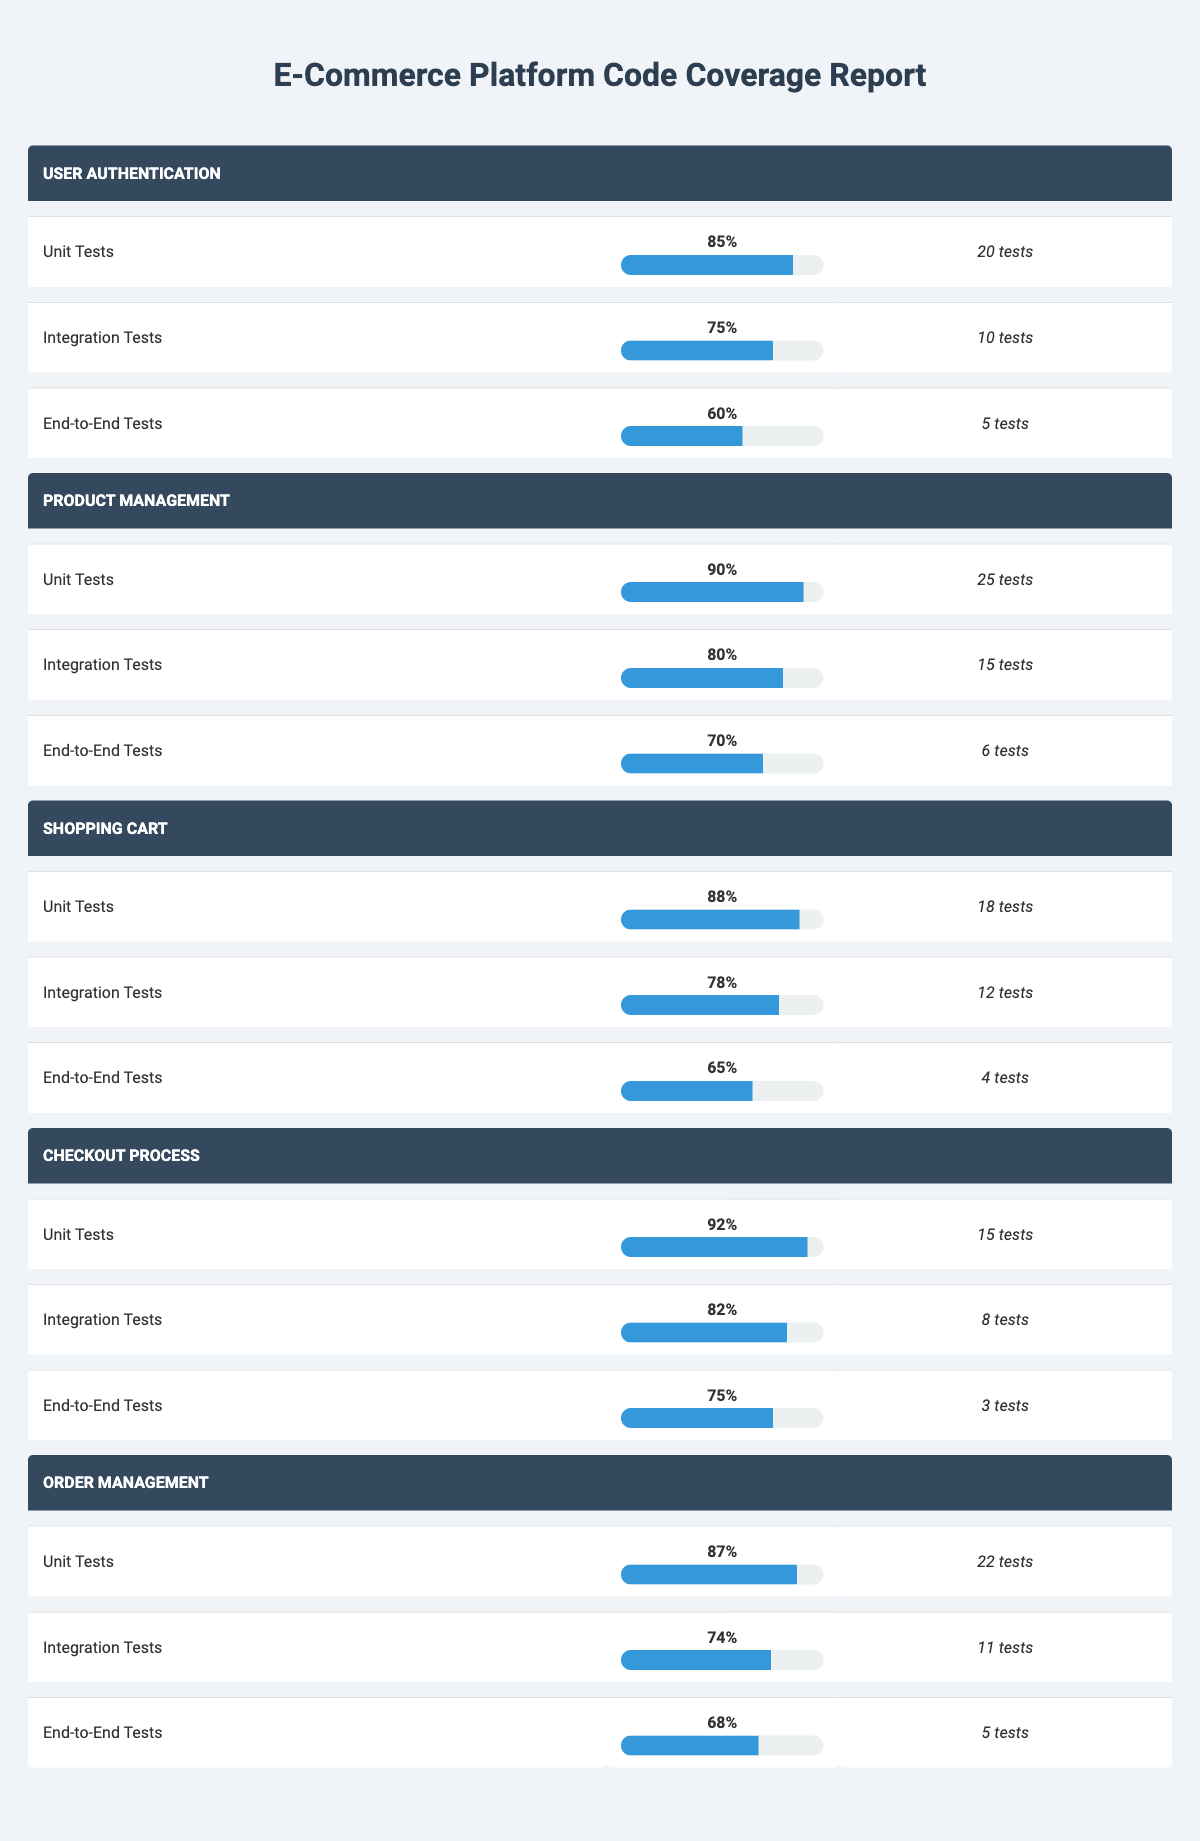What is the coverage percentage for Unit Tests in the Checkout Process module? The coverage percentage for Unit Tests in the Checkout Process module is listed directly in the table under the respective module and test type row. It shows 92% as the coverage for Unit Tests in that module.
Answer: 92% Which module has the lowest coverage percentage for End-to-End Tests? By comparing the coverage percentages for End-to-End Tests across all modules in the table, we see that the lowest percentage is 60% for the User Authentication module.
Answer: User Authentication What is the average coverage percentage for Integration Tests across all modules? To find the average coverage percentage for Integration Tests, we add the individual percentages (75 + 80 + 78 + 82 + 74 = 389) and then divide by the number of modules, which is 5. Therefore, 389/5 = 77.8%.
Answer: 77.8% Is the coverage percentage for Unit Tests in the Shopping Cart module higher than that in the Order Management module? The coverage percentage for Unit Tests in the Shopping Cart module is 88%, while in the Order Management module it is 87%. Comparing these two values shows that 88% is greater than 87%.
Answer: Yes What is the total number of tests conducted for Integration Tests across all modules? To get the total number of tests for Integration Tests, we sum the number of tests for that category in each module (10 + 15 + 12 + 8 + 11 = 56). The result indicates the total tests executed for Integration Tests.
Answer: 56 Which module has the highest number of Unit Tests? The table indicates that the Product Management module has 25 Unit Tests, which is the highest count compared to the other modules.
Answer: Product Management What is the difference in coverage percentage for End-to-End Tests between the Checkout Process module and Shopping Cart module? The coverage percentage for End-to-End Tests in the Checkout Process module is 75%, while for Shopping Cart, it is 65%. The difference is calculated by subtracting 65 from 75, resulting in a difference of 10%.
Answer: 10% Are there more Integration Tests in the User Authentication module than in the Checkout Process module? The User Authentication module has 10 Integration Tests, while the Checkout Process has 8. Since 10 is greater than 8, the statement is true.
Answer: Yes What is the median coverage percentage for all test types across the Product Management module? The coverage percentages for the Product Management module are 90% for Unit Tests, 80% for Integration Tests, and 70% for End-to-End Tests. Arranging these values gives (70, 80, 90). The median is the middle value, which is 80%.
Answer: 80% 